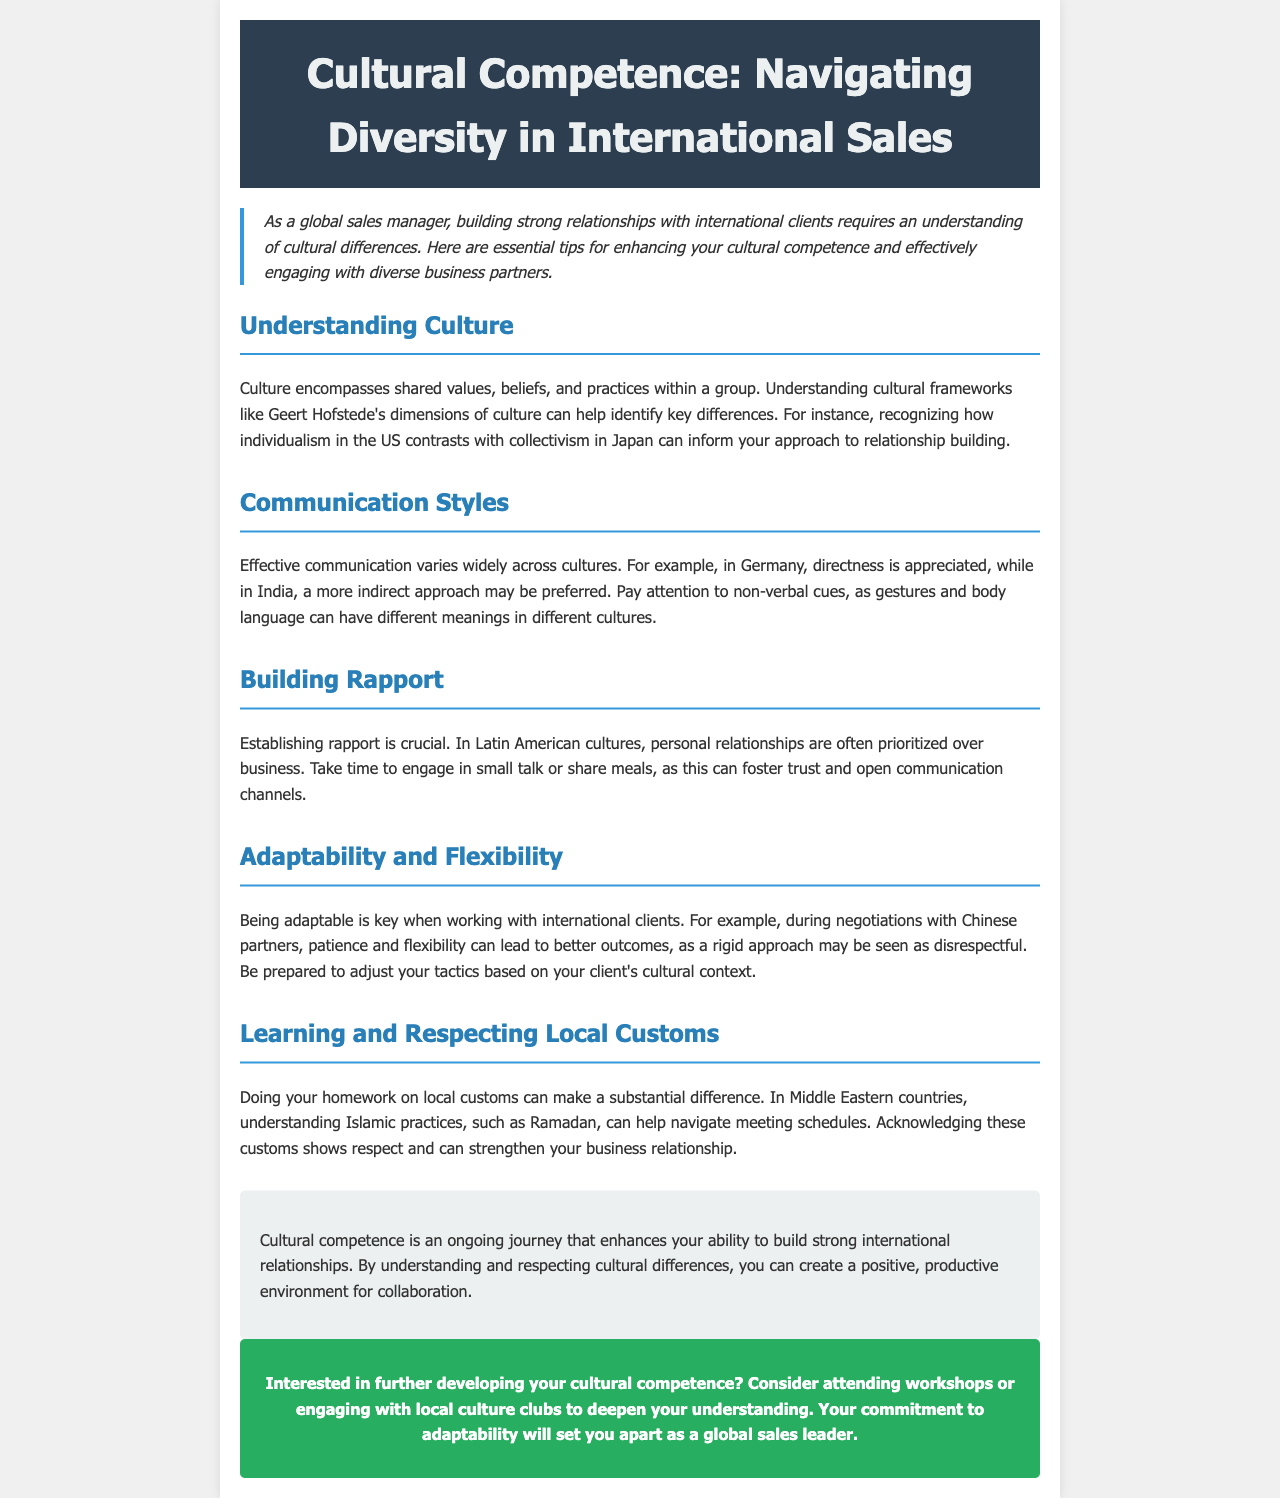What is the title of the newsletter? The title of the newsletter is specifically stated at the beginning of the document.
Answer: Cultural Competence: Navigating Diversity in International Sales What cultural framework is mentioned in the document? The document references a specific cultural framework created by a notable researcher in the field of intercultural studies.
Answer: Geert Hofstede's dimensions of culture Which country values direct communication according to the newsletter? The document specifies a particular European country that appreciates directness in communication styles.
Answer: Germany What is prioritized in Latin American cultures according to the text? The text discusses regional cultural norms, specifically mentioning what is more important than business in these cultures.
Answer: Personal relationships What should you do to show respect in Middle Eastern countries? The document explains the importance of understanding specific practices in the region to show appreciation for local traditions.
Answer: Acknowledge Islamic practices What aspect is crucial when working with international clients? The document emphasizes an important trait that enhances interactions with diverse clients in the context of flexibility.
Answer: Adaptability Which season is mentioned that influences meeting schedules in Islamic customs? The document highlights a specific period that significantly affects the timing of meetings in Islamic culture.
Answer: Ramadan What kind of activities does the document suggest for developing cultural competence? The newsletter offers specific recommendations for gaining a better understanding of different cultures through participatory experiences.
Answer: Workshops or local culture clubs 